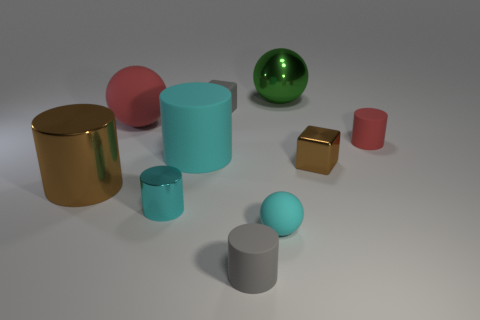What is the material of the brown cube that is the same size as the red matte cylinder?
Ensure brevity in your answer.  Metal. How many objects are small cyan matte balls or rubber objects that are to the right of the gray matte cube?
Provide a succinct answer. 3. There is a brown cylinder; is it the same size as the red thing that is right of the small brown thing?
Provide a short and direct response. No. What number of cylinders are either tiny cyan metal objects or cyan things?
Keep it short and to the point. 2. What number of rubber balls are both on the right side of the tiny gray cylinder and behind the brown shiny block?
Offer a very short reply. 0. What number of other objects are there of the same color as the small rubber sphere?
Ensure brevity in your answer.  2. There is a gray matte object that is in front of the large shiny cylinder; what is its shape?
Offer a very short reply. Cylinder. Is the material of the gray cylinder the same as the green sphere?
Provide a succinct answer. No. Is there anything else that has the same size as the green sphere?
Keep it short and to the point. Yes. How many blocks are left of the big red sphere?
Provide a short and direct response. 0. 